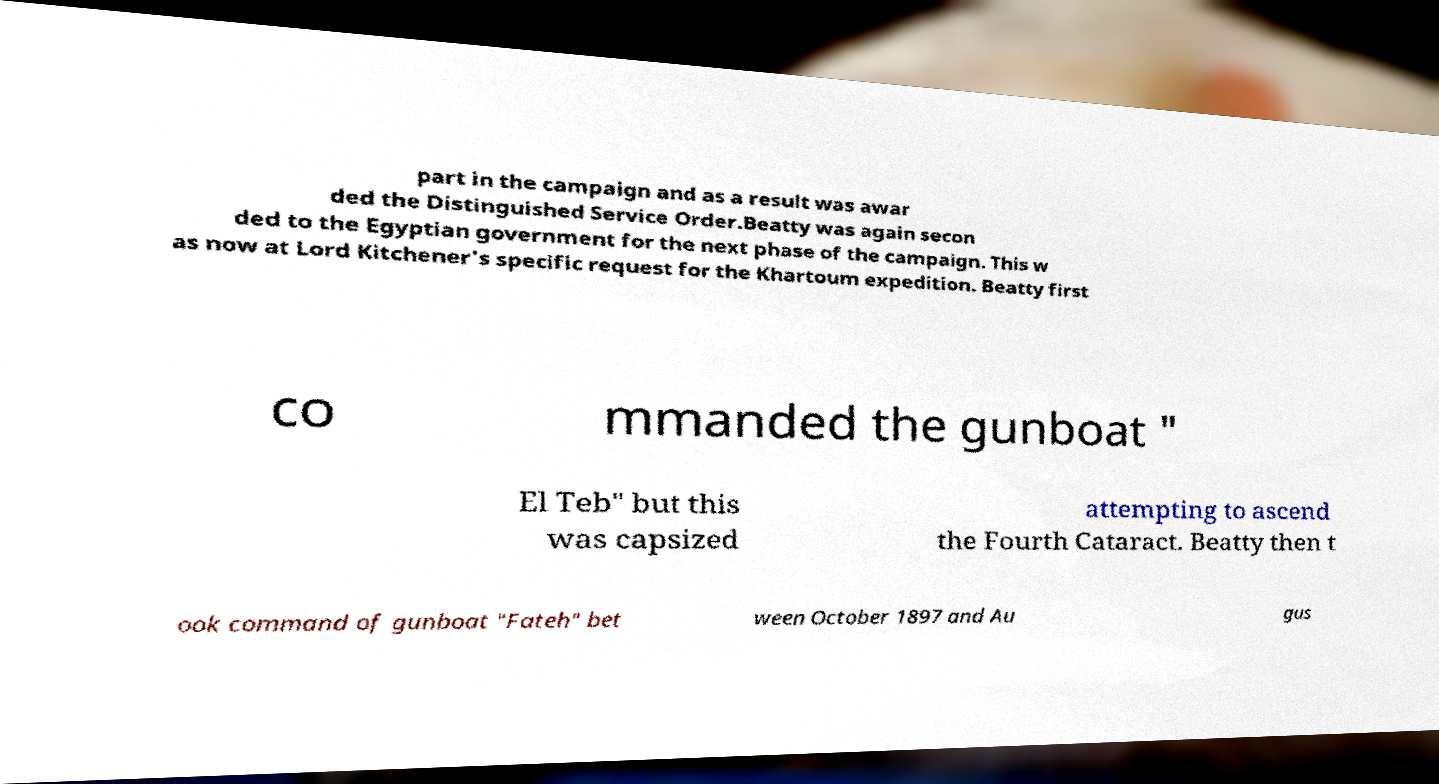Please identify and transcribe the text found in this image. part in the campaign and as a result was awar ded the Distinguished Service Order.Beatty was again secon ded to the Egyptian government for the next phase of the campaign. This w as now at Lord Kitchener's specific request for the Khartoum expedition. Beatty first co mmanded the gunboat " El Teb" but this was capsized attempting to ascend the Fourth Cataract. Beatty then t ook command of gunboat "Fateh" bet ween October 1897 and Au gus 